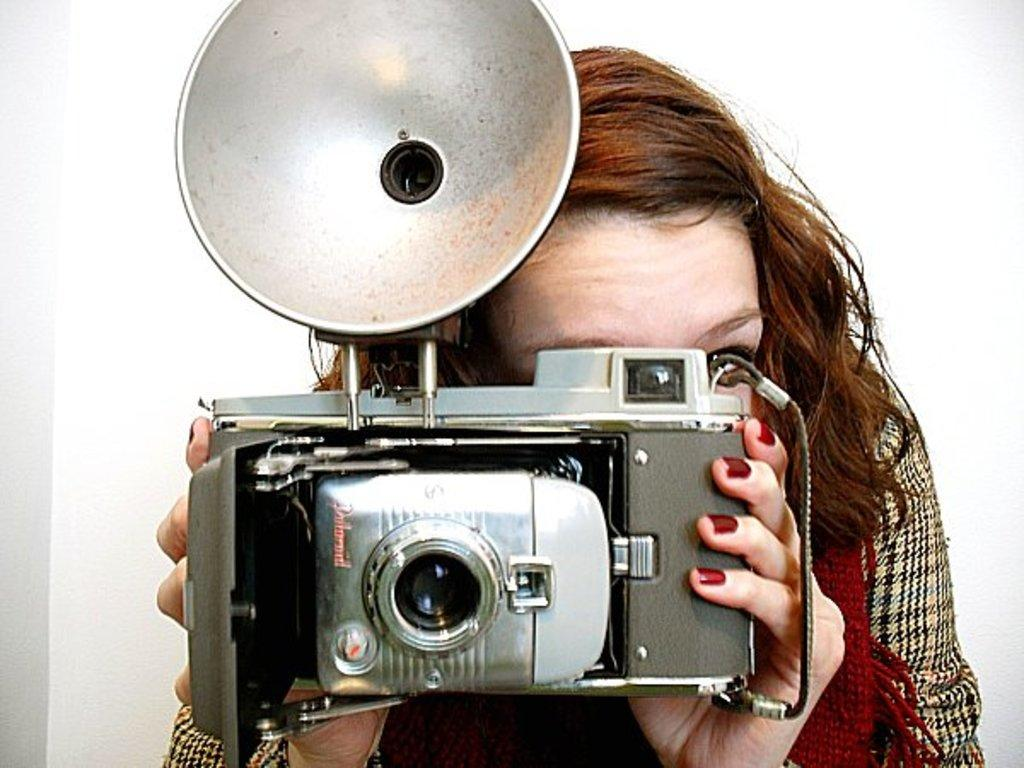What is the main subject of the image? The main subject of the image is a woman. What is the woman holding in the image? The woman is holding a camera. What can be seen in the background of the image? There is a white wall in the background of the image. What is the chance of the woman winning a match with a pen in the image? There is no indication of a match or a pen in the image, so it's not possible to determine the chance of the woman winning a match with a pen. 